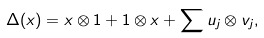<formula> <loc_0><loc_0><loc_500><loc_500>\Delta ( x ) = x \otimes 1 + 1 \otimes x + \sum u _ { j } \otimes v _ { j } ,</formula> 